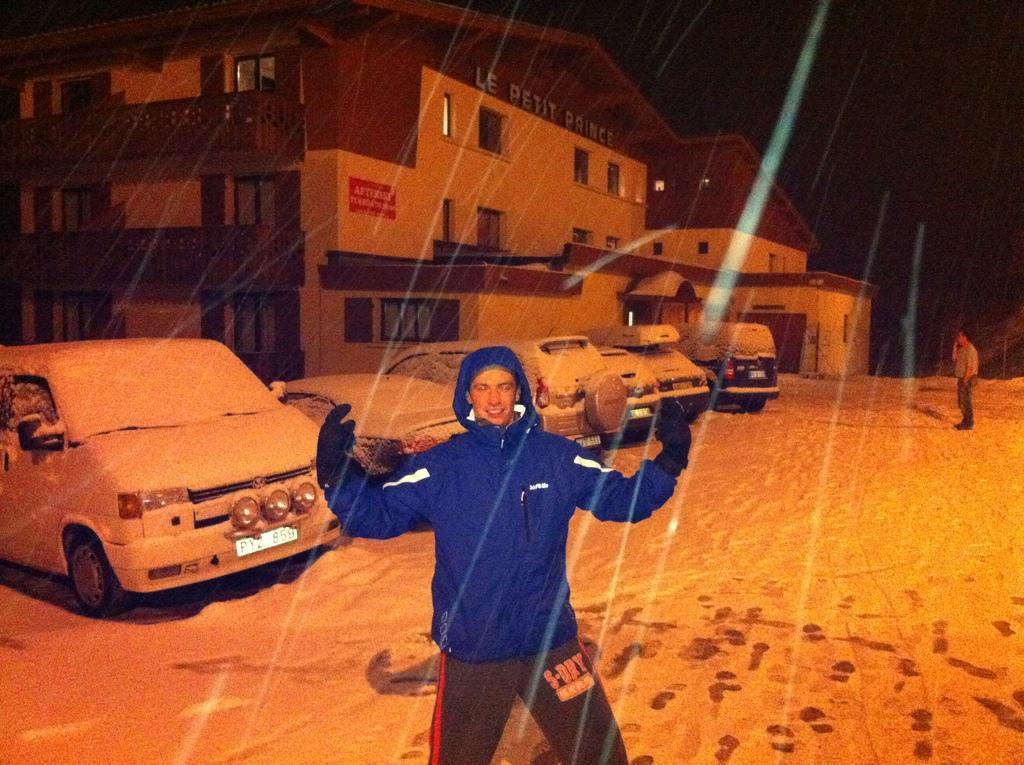Please provide a concise description of this image. In this image I can see two men are standing. In the background I can see building, vehicles and the sky. 